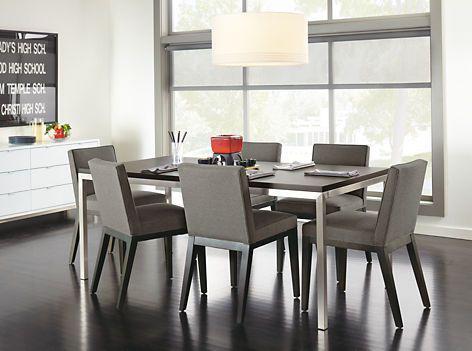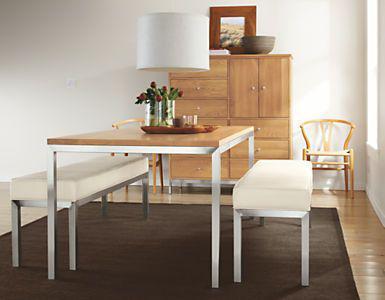The first image is the image on the left, the second image is the image on the right. Assess this claim about the two images: "One image includes a white table with white chairs that feature molded seats.". Correct or not? Answer yes or no. No. The first image is the image on the left, the second image is the image on the right. Evaluate the accuracy of this statement regarding the images: "Two rectangular dining tables have chairs only on both long sides.". Is it true? Answer yes or no. No. 